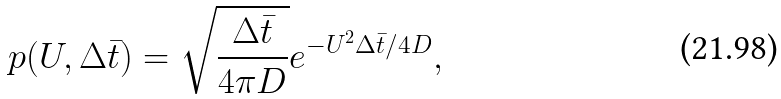<formula> <loc_0><loc_0><loc_500><loc_500>p ( U , \Delta \bar { t } ) = \sqrt { \frac { \Delta \bar { t } } { 4 \pi D } } e ^ { - U ^ { 2 } \Delta \bar { t } / 4 D } ,</formula> 